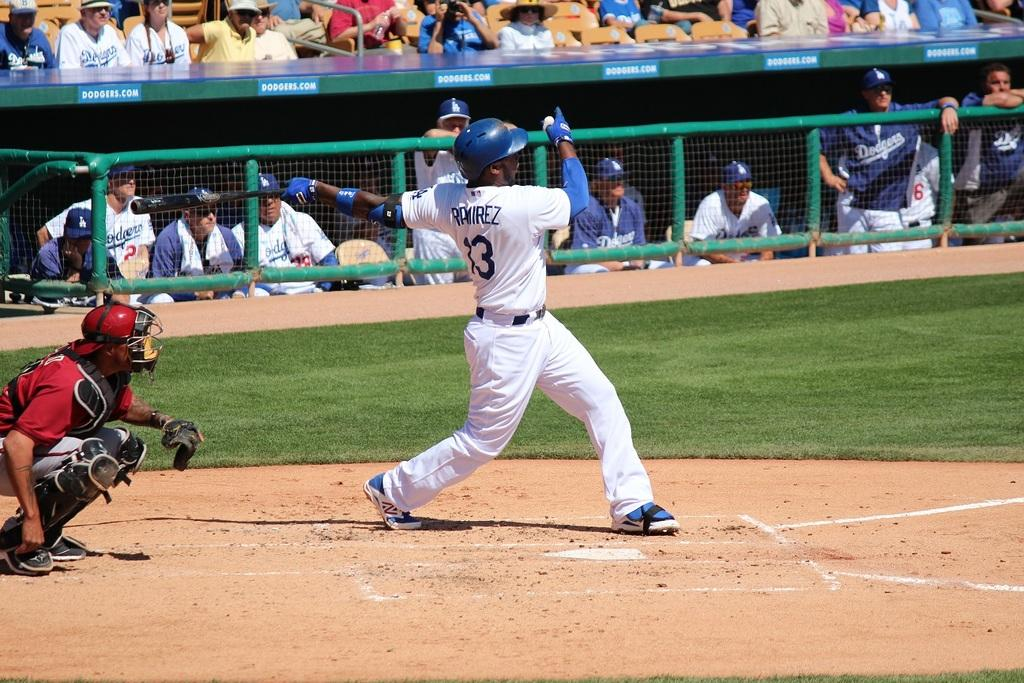<image>
Provide a brief description of the given image. A baseball player named Ramirez swings a bat at home plate while everybody watches. 